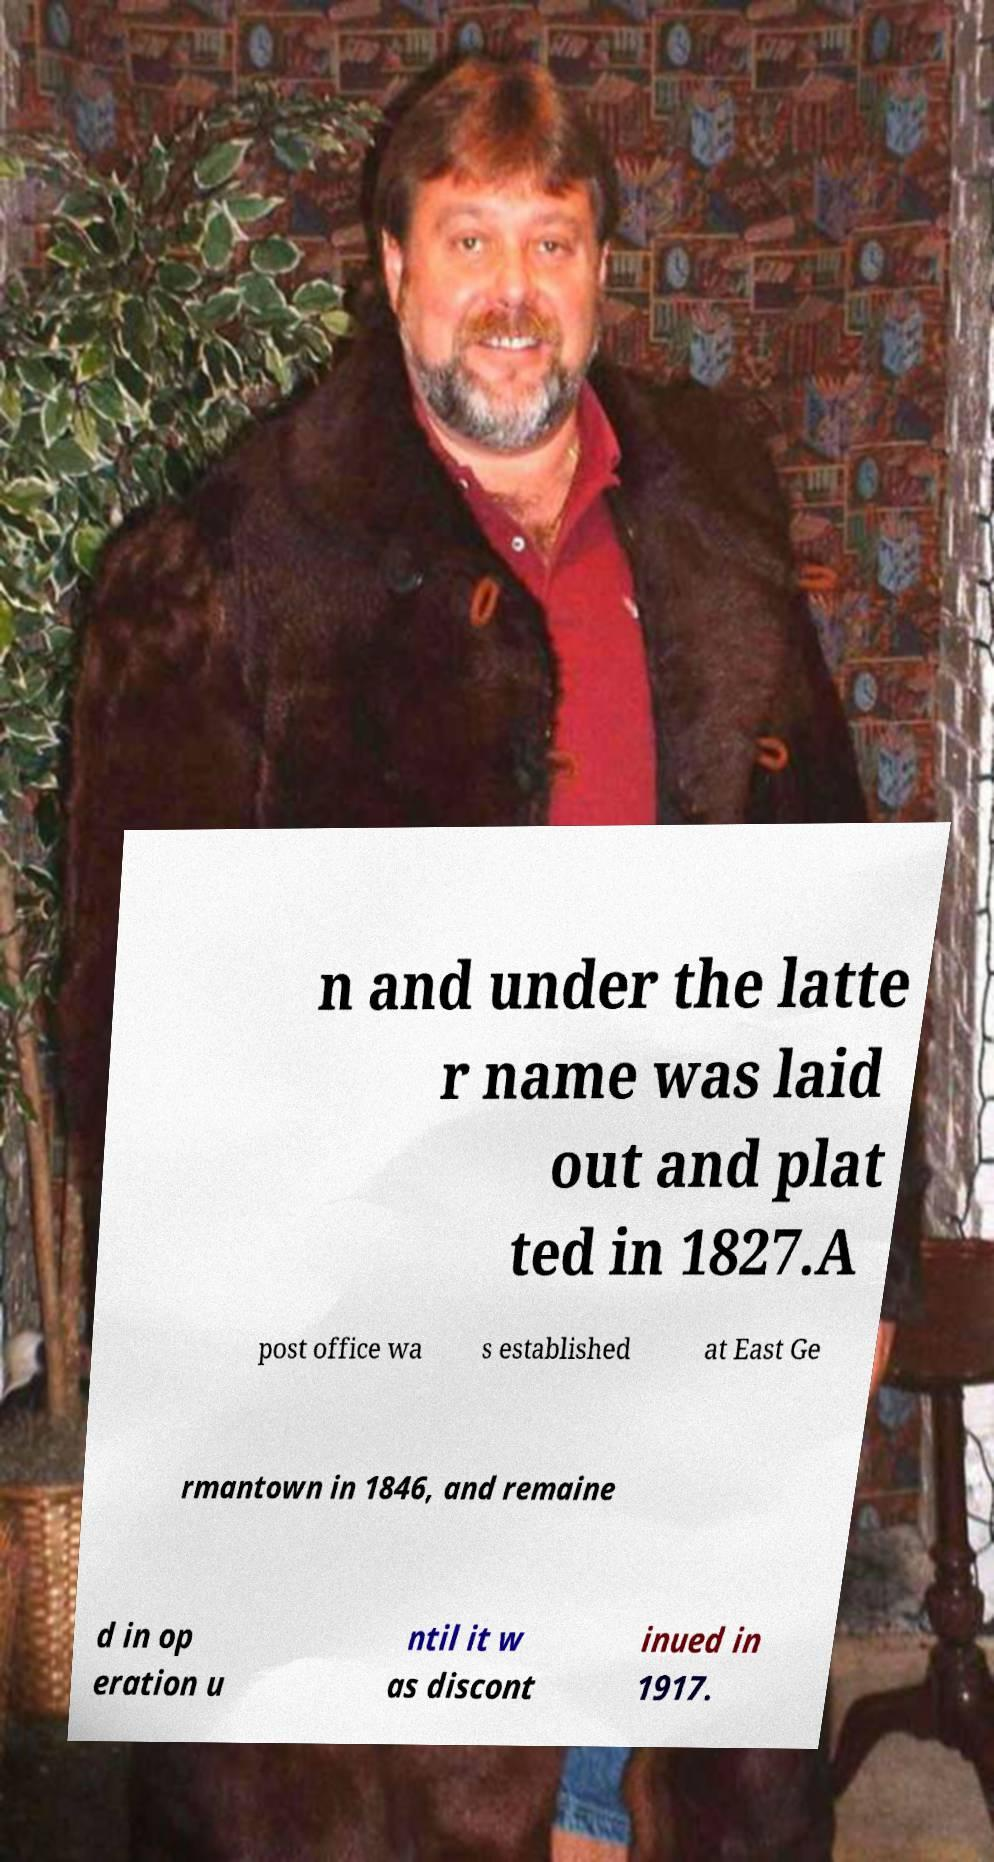What messages or text are displayed in this image? I need them in a readable, typed format. n and under the latte r name was laid out and plat ted in 1827.A post office wa s established at East Ge rmantown in 1846, and remaine d in op eration u ntil it w as discont inued in 1917. 